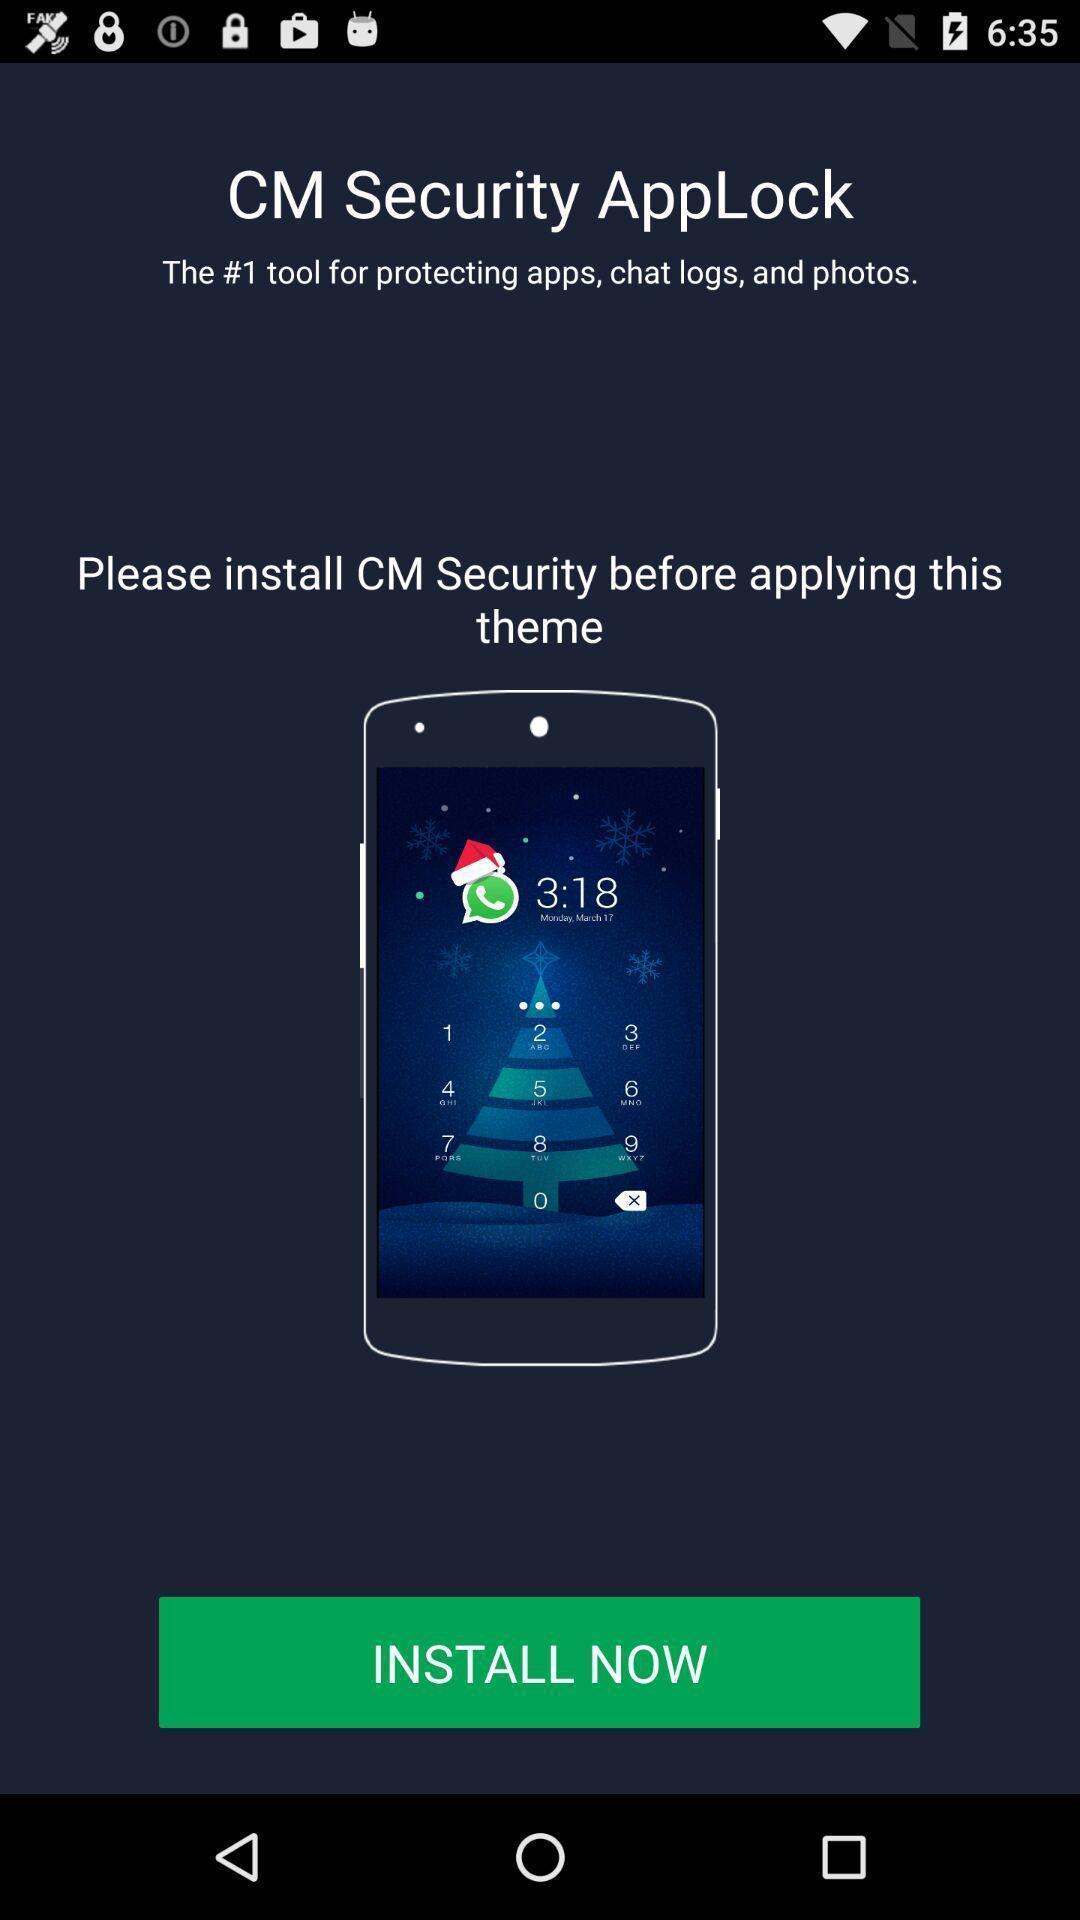Tell me about the visual elements in this screen capture. Page showing an advertisement to install the security app. 